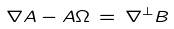Convert formula to latex. <formula><loc_0><loc_0><loc_500><loc_500>\nabla A - A \Omega \, = \, \nabla ^ { \perp } B</formula> 